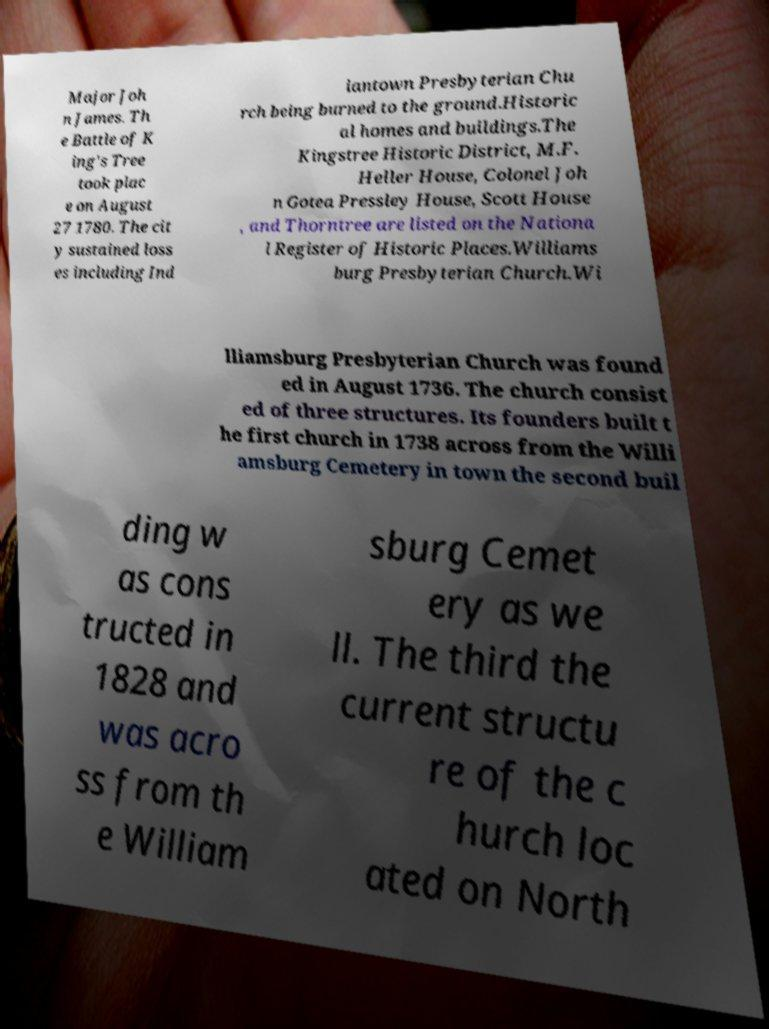Please read and relay the text visible in this image. What does it say? Major Joh n James. Th e Battle of K ing's Tree took plac e on August 27 1780. The cit y sustained loss es including Ind iantown Presbyterian Chu rch being burned to the ground.Historic al homes and buildings.The Kingstree Historic District, M.F. Heller House, Colonel Joh n Gotea Pressley House, Scott House , and Thorntree are listed on the Nationa l Register of Historic Places.Williams burg Presbyterian Church.Wi lliamsburg Presbyterian Church was found ed in August 1736. The church consist ed of three structures. Its founders built t he first church in 1738 across from the Willi amsburg Cemetery in town the second buil ding w as cons tructed in 1828 and was acro ss from th e William sburg Cemet ery as we ll. The third the current structu re of the c hurch loc ated on North 